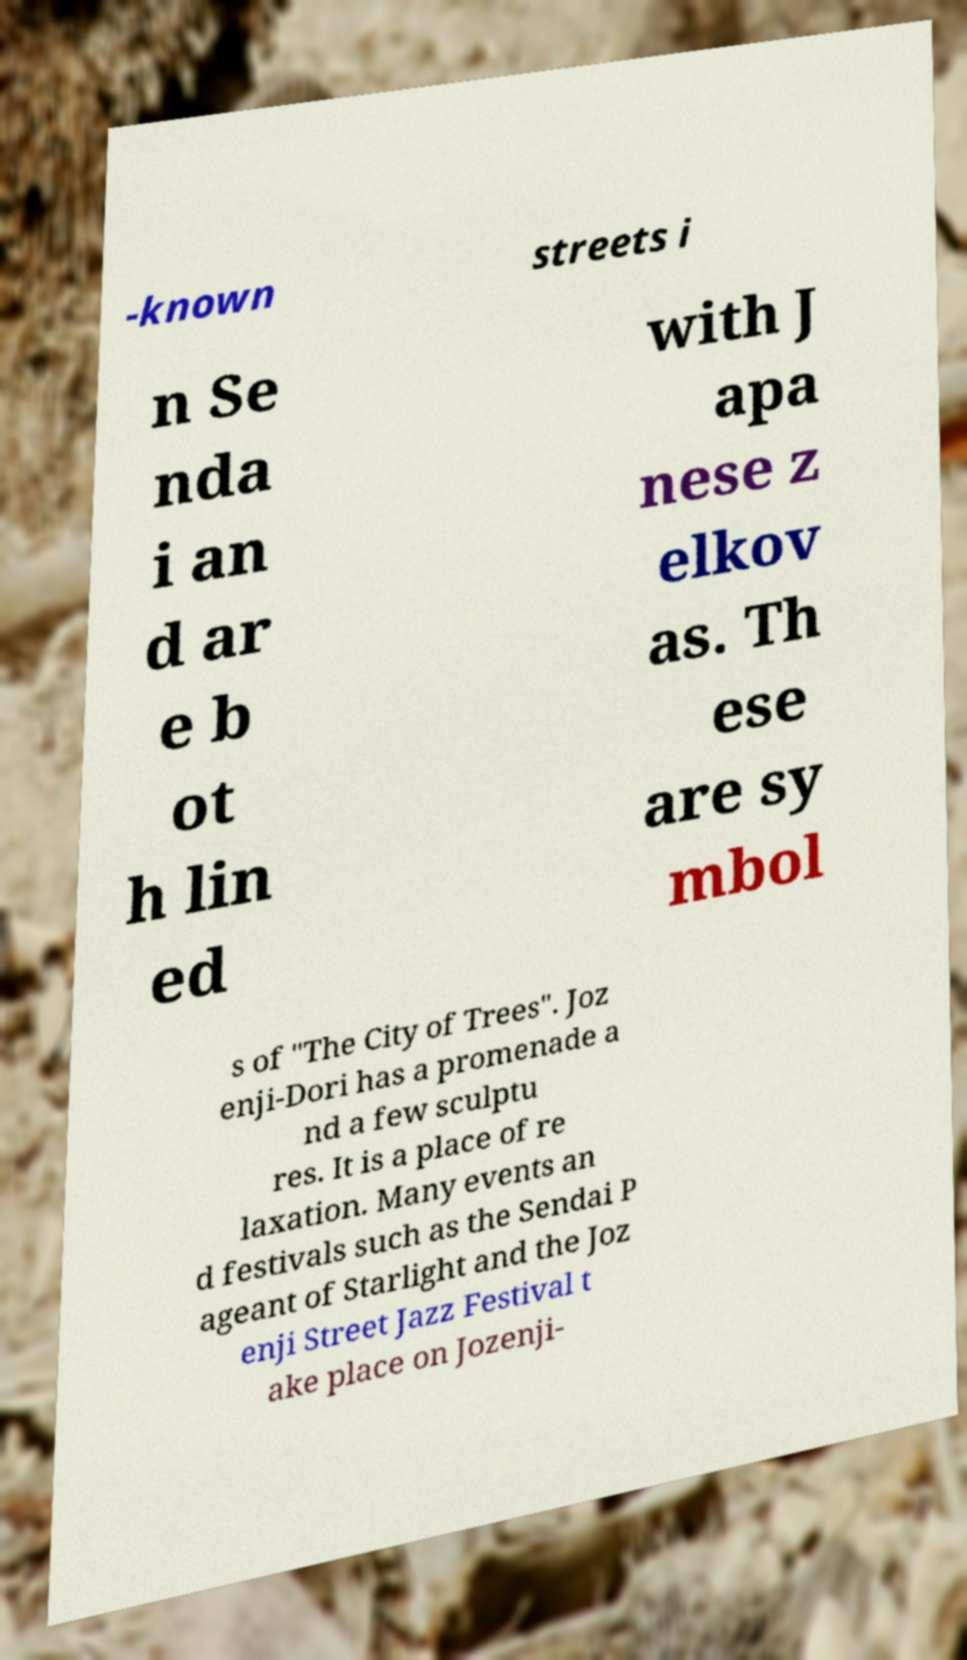Please read and relay the text visible in this image. What does it say? -known streets i n Se nda i an d ar e b ot h lin ed with J apa nese z elkov as. Th ese are sy mbol s of "The City of Trees". Joz enji-Dori has a promenade a nd a few sculptu res. It is a place of re laxation. Many events an d festivals such as the Sendai P ageant of Starlight and the Joz enji Street Jazz Festival t ake place on Jozenji- 